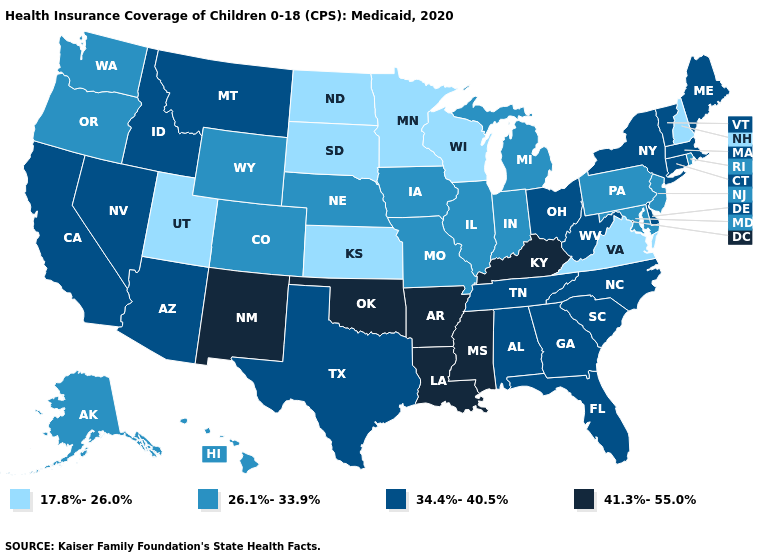Does the first symbol in the legend represent the smallest category?
Be succinct. Yes. What is the lowest value in the Northeast?
Keep it brief. 17.8%-26.0%. Does New Jersey have the lowest value in the Northeast?
Concise answer only. No. Name the states that have a value in the range 41.3%-55.0%?
Be succinct. Arkansas, Kentucky, Louisiana, Mississippi, New Mexico, Oklahoma. Does Pennsylvania have a higher value than South Dakota?
Short answer required. Yes. What is the value of Pennsylvania?
Short answer required. 26.1%-33.9%. What is the value of Georgia?
Short answer required. 34.4%-40.5%. Name the states that have a value in the range 26.1%-33.9%?
Answer briefly. Alaska, Colorado, Hawaii, Illinois, Indiana, Iowa, Maryland, Michigan, Missouri, Nebraska, New Jersey, Oregon, Pennsylvania, Rhode Island, Washington, Wyoming. Among the states that border South Dakota , which have the lowest value?
Concise answer only. Minnesota, North Dakota. What is the value of Wyoming?
Answer briefly. 26.1%-33.9%. What is the value of New York?
Quick response, please. 34.4%-40.5%. What is the highest value in the USA?
Answer briefly. 41.3%-55.0%. Does Ohio have the lowest value in the USA?
Short answer required. No. What is the highest value in the USA?
Quick response, please. 41.3%-55.0%. 